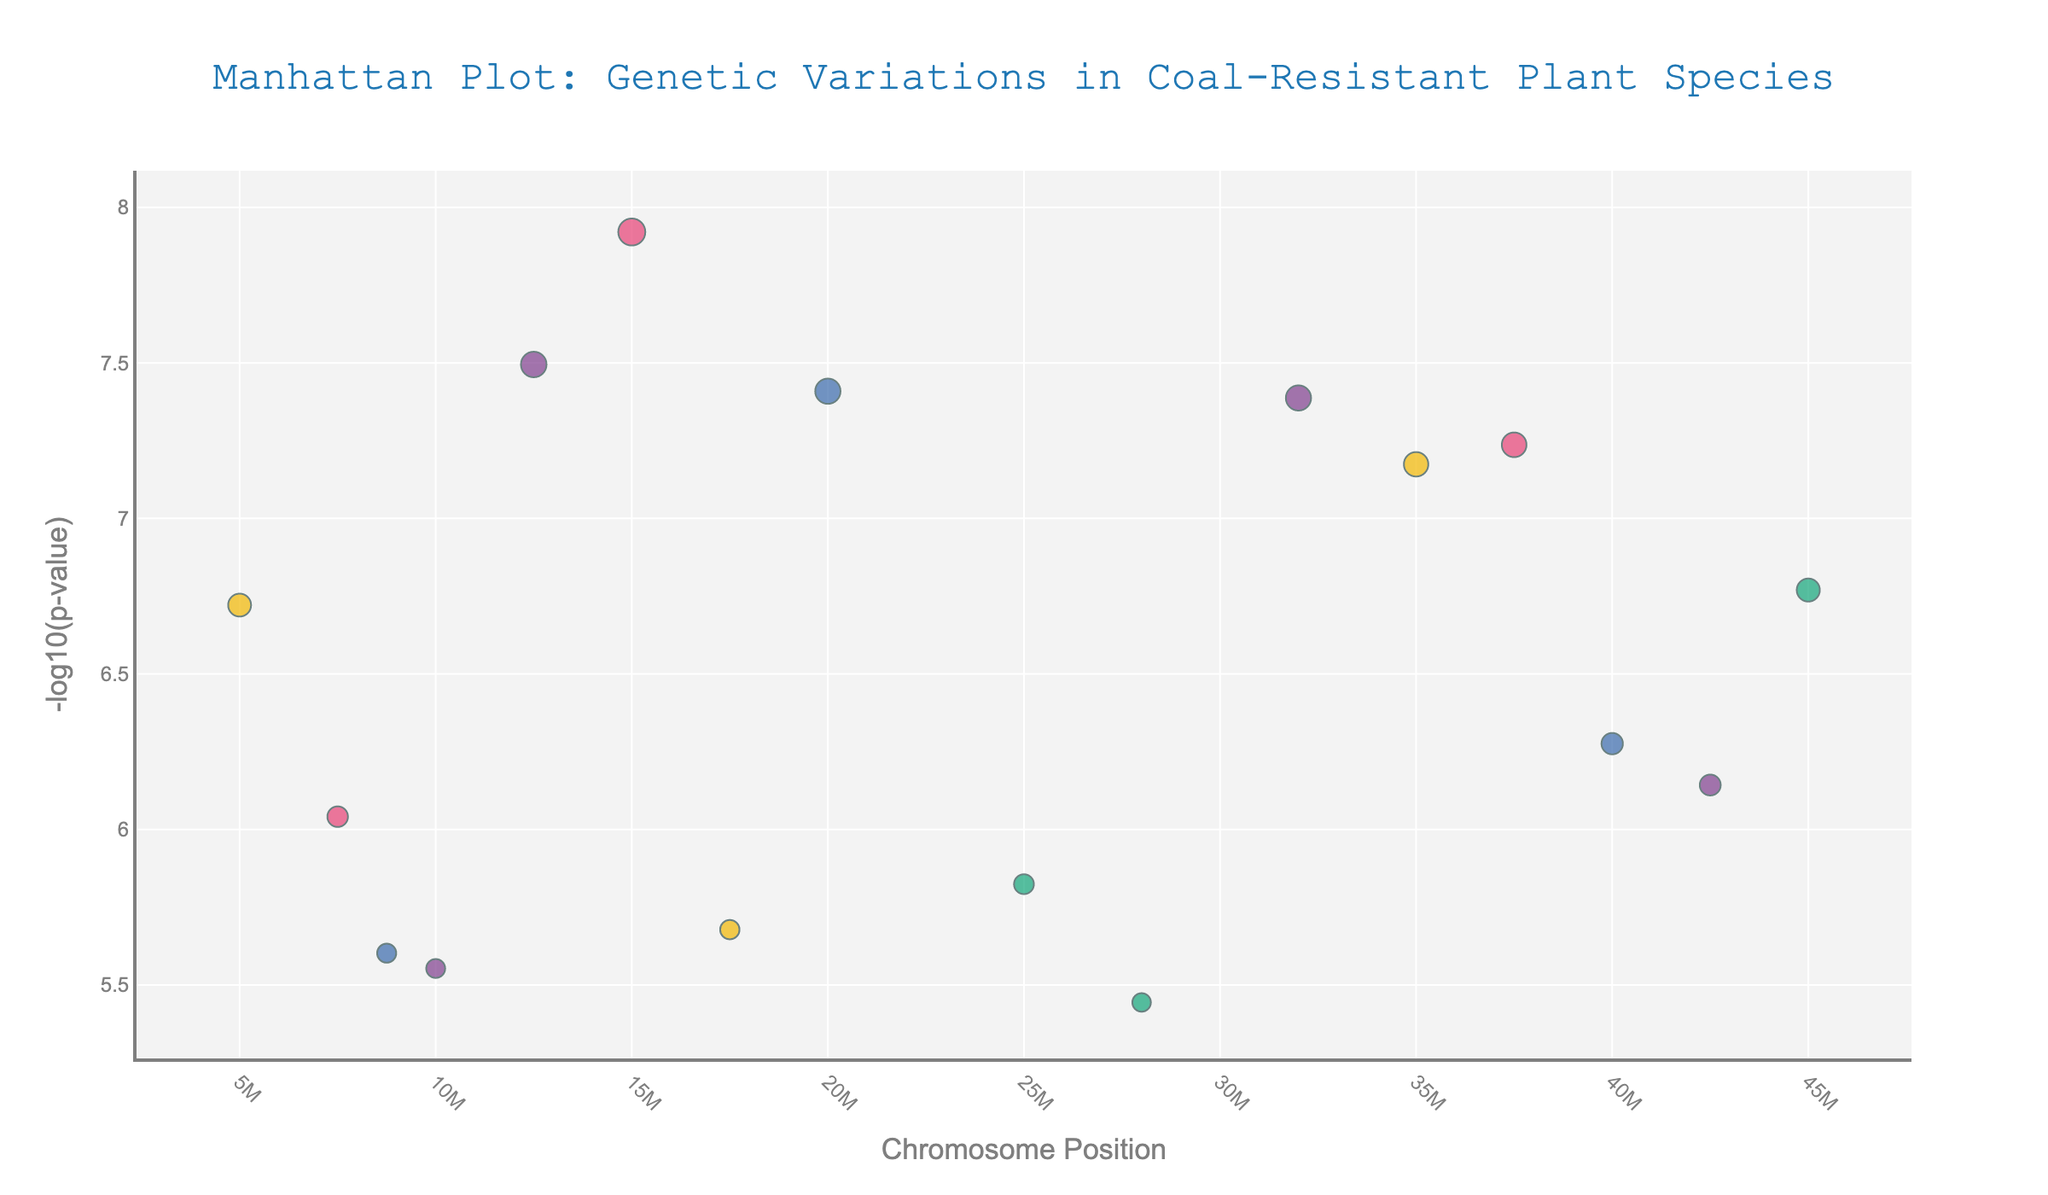What is the title of the plot? The title is positioned at the top of the plot and is meant to describe the figure briefly. This title mentions genetic variations in coal-resistant plant species.
Answer: Manhattan Plot: Genetic Variations in Coal-Resistant Plant Species What is the y-axis representing in the plot? The y-axis label indicates the type of values being plotted. Here, "-log10(p-value)" means it shows the negative logarithm of the p-value, which highlights the significance of genetic variations.
Answer: -log10(p-value) Which chromosome has the genetic variant with the lowest p-value? To determine this, we look for the highest -log10(p-value) on the y-axis as it correlates with the lowest p-value. This point is on Chromosome 1.
Answer: Chromosome 1 Which plant species has the most significant genetic variation on Chromosome 5? First, identify the data points on Chromosome 5, then check which plant species corresponds to the highest -log10(p-value). Deschampsia flexuosa is the species with the most significant point on Chromosome 5.
Answer: Deschampsia flexuosa How many data points are plotted for Chromosome 4? Count the number of data points or markers specifically located along the x-axis region designated for Chromosome 4. There are two points.
Answer: 2 Among the plant species, which one has points across the most number of chromosomes? To find this, count the number of unique chromosomes that have data points for each plant species. Betula pendula has data points across the most different chromosomes.
Answer: Betula pendula What is the maximum -log10(p-value) for Populus tremula, and on which chromosome does it occur? Identify the data points related to Populus tremula and check their corresponding y-values and chromosomes. The highest -log10(p-value) for Populus tremula is on Chromosome 1 with a value of -log10(1.7e-7).
Answer: Chromosome 1, -log10(1.7e-7) Compare the significance of genetic variations for Betula pendula on Chromosome 1 and Chromosome 7. Which one is more significant and by how much? First, find the -log10(p-value) for Betula pendula on both Chromosome 1 and Chromosome 7. Chromosome 1 has -log10(3.2e-8), and Chromosome 7 has -log10(7.2e-7). Subtract the two -log10(p-values) to get the comparison.
Answer: Chromosome 1; by approximately 1.56 What species exhibits the strongest genetic variation on Chromosome 4? Check the y-values for data points on Chromosome 4 and identify the species with the highest -log10(p-value), which indicates the strongest genetic variation. Calamagrostis epigejos is the species with the highest point.
Answer: Calamagrostis epigejos 